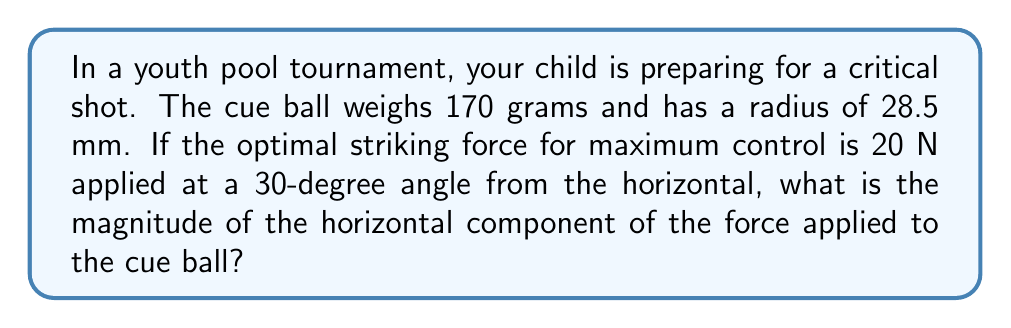Can you solve this math problem? To solve this problem, we'll follow these steps:

1) First, let's recall the trigonometric relationship for finding the horizontal component of a force:

   $F_x = F \cos(\theta)$

   Where $F_x$ is the horizontal component of the force, $F$ is the total force, and $\theta$ is the angle from the horizontal.

2) We're given:
   - Total force $F = 20$ N
   - Angle $\theta = 30°$

3) Now, let's substitute these values into our equation:

   $F_x = 20 \cos(30°)$

4) We know that $\cos(30°) = \frac{\sqrt{3}}{2}$, so:

   $F_x = 20 \cdot \frac{\sqrt{3}}{2}$

5) Simplify:

   $F_x = 10\sqrt{3}$ N

6) If we want to express this as a decimal, we can calculate:

   $F_x \approx 17.32$ N

Note: While the mass and radius of the cue ball were given in the problem, they weren't necessary for this calculation. However, they're important factors in determining the overall control and behavior of the ball after it's struck.
Answer: $10\sqrt{3}$ N or approximately 17.32 N 